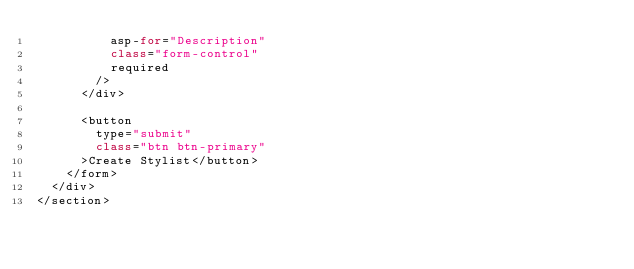<code> <loc_0><loc_0><loc_500><loc_500><_C#_>          asp-for="Description"
          class="form-control"
          required
        />
      </div>

      <button 
        type="submit"
        class="btn btn-primary"
      >Create Stylist</button>
    </form>
  </div>
</section></code> 